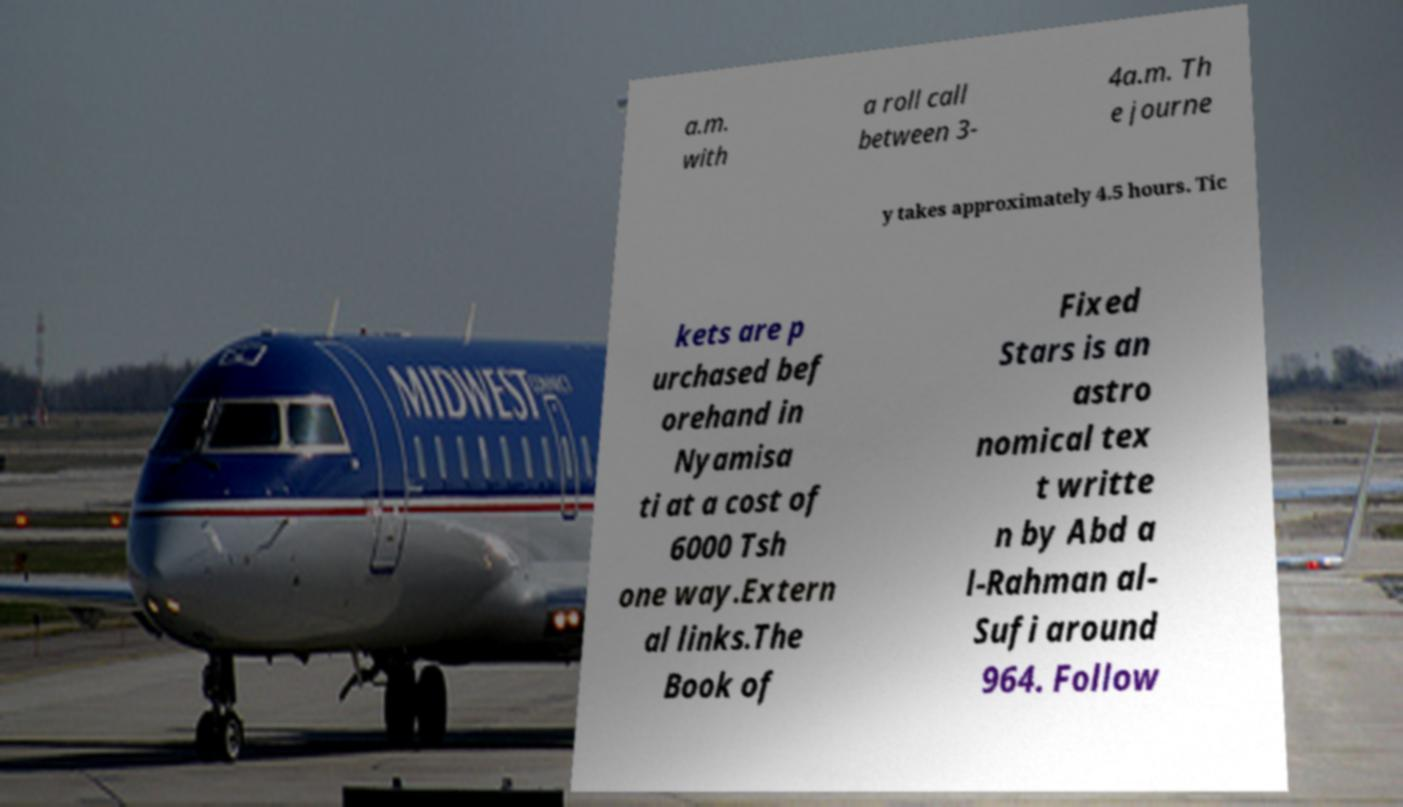Can you read and provide the text displayed in the image?This photo seems to have some interesting text. Can you extract and type it out for me? a.m. with a roll call between 3- 4a.m. Th e journe y takes approximately 4.5 hours. Tic kets are p urchased bef orehand in Nyamisa ti at a cost of 6000 Tsh one way.Extern al links.The Book of Fixed Stars is an astro nomical tex t writte n by Abd a l-Rahman al- Sufi around 964. Follow 